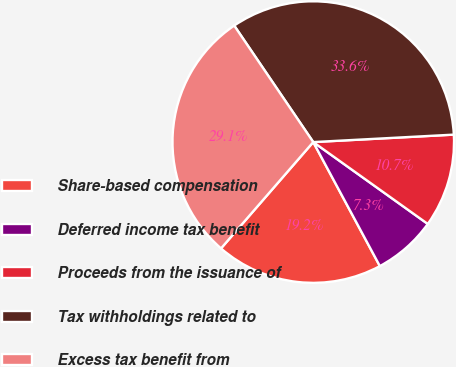<chart> <loc_0><loc_0><loc_500><loc_500><pie_chart><fcel>Share-based compensation<fcel>Deferred income tax benefit<fcel>Proceeds from the issuance of<fcel>Tax withholdings related to<fcel>Excess tax benefit from<nl><fcel>19.22%<fcel>7.28%<fcel>10.72%<fcel>33.65%<fcel>29.14%<nl></chart> 